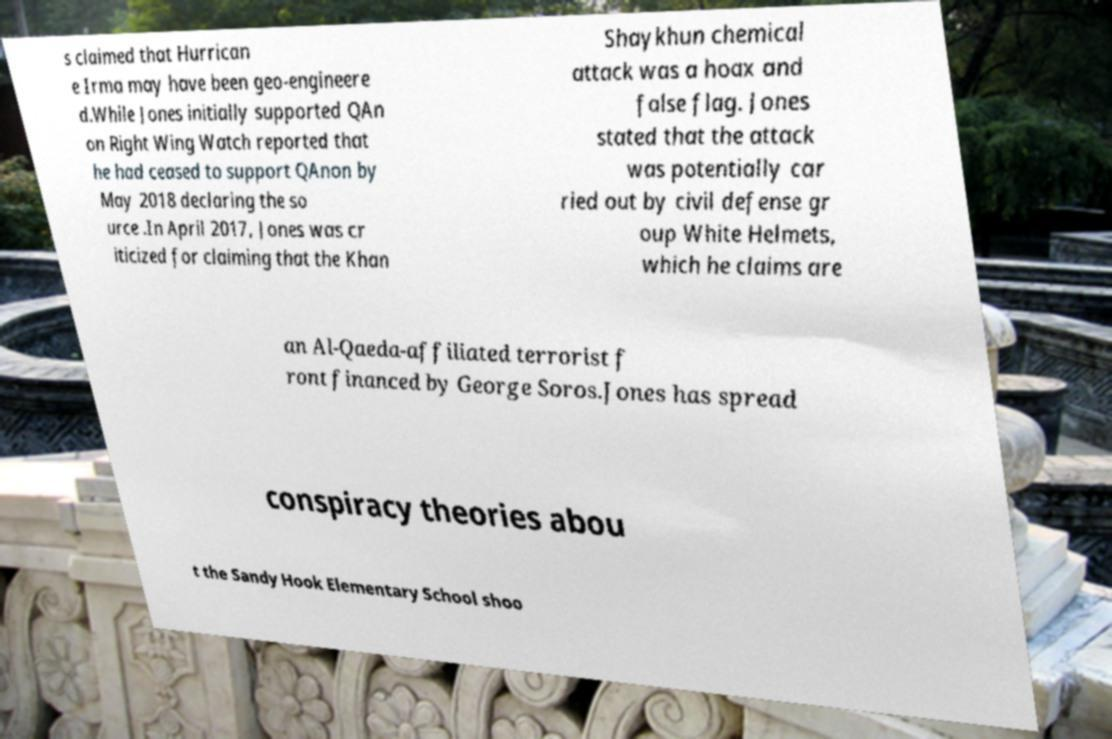There's text embedded in this image that I need extracted. Can you transcribe it verbatim? s claimed that Hurrican e Irma may have been geo-engineere d.While Jones initially supported QAn on Right Wing Watch reported that he had ceased to support QAnon by May 2018 declaring the so urce .In April 2017, Jones was cr iticized for claiming that the Khan Shaykhun chemical attack was a hoax and false flag. Jones stated that the attack was potentially car ried out by civil defense gr oup White Helmets, which he claims are an Al-Qaeda-affiliated terrorist f ront financed by George Soros.Jones has spread conspiracy theories abou t the Sandy Hook Elementary School shoo 